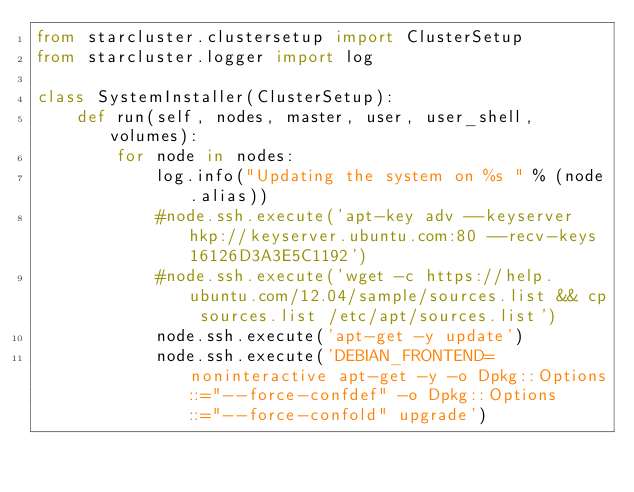Convert code to text. <code><loc_0><loc_0><loc_500><loc_500><_Python_>from starcluster.clustersetup import ClusterSetup
from starcluster.logger import log

class SystemInstaller(ClusterSetup):
	def run(self, nodes, master, user, user_shell, volumes):
		for node in nodes:
			log.info("Updating the system on %s " % (node.alias))
			#node.ssh.execute('apt-key adv --keyserver hkp://keyserver.ubuntu.com:80 --recv-keys 16126D3A3E5C1192')
			#node.ssh.execute('wget -c https://help.ubuntu.com/12.04/sample/sources.list && cp sources.list /etc/apt/sources.list')
			node.ssh.execute('apt-get -y update')
			node.ssh.execute('DEBIAN_FRONTEND=noninteractive apt-get -y -o Dpkg::Options::="--force-confdef" -o Dpkg::Options::="--force-confold" upgrade')</code> 